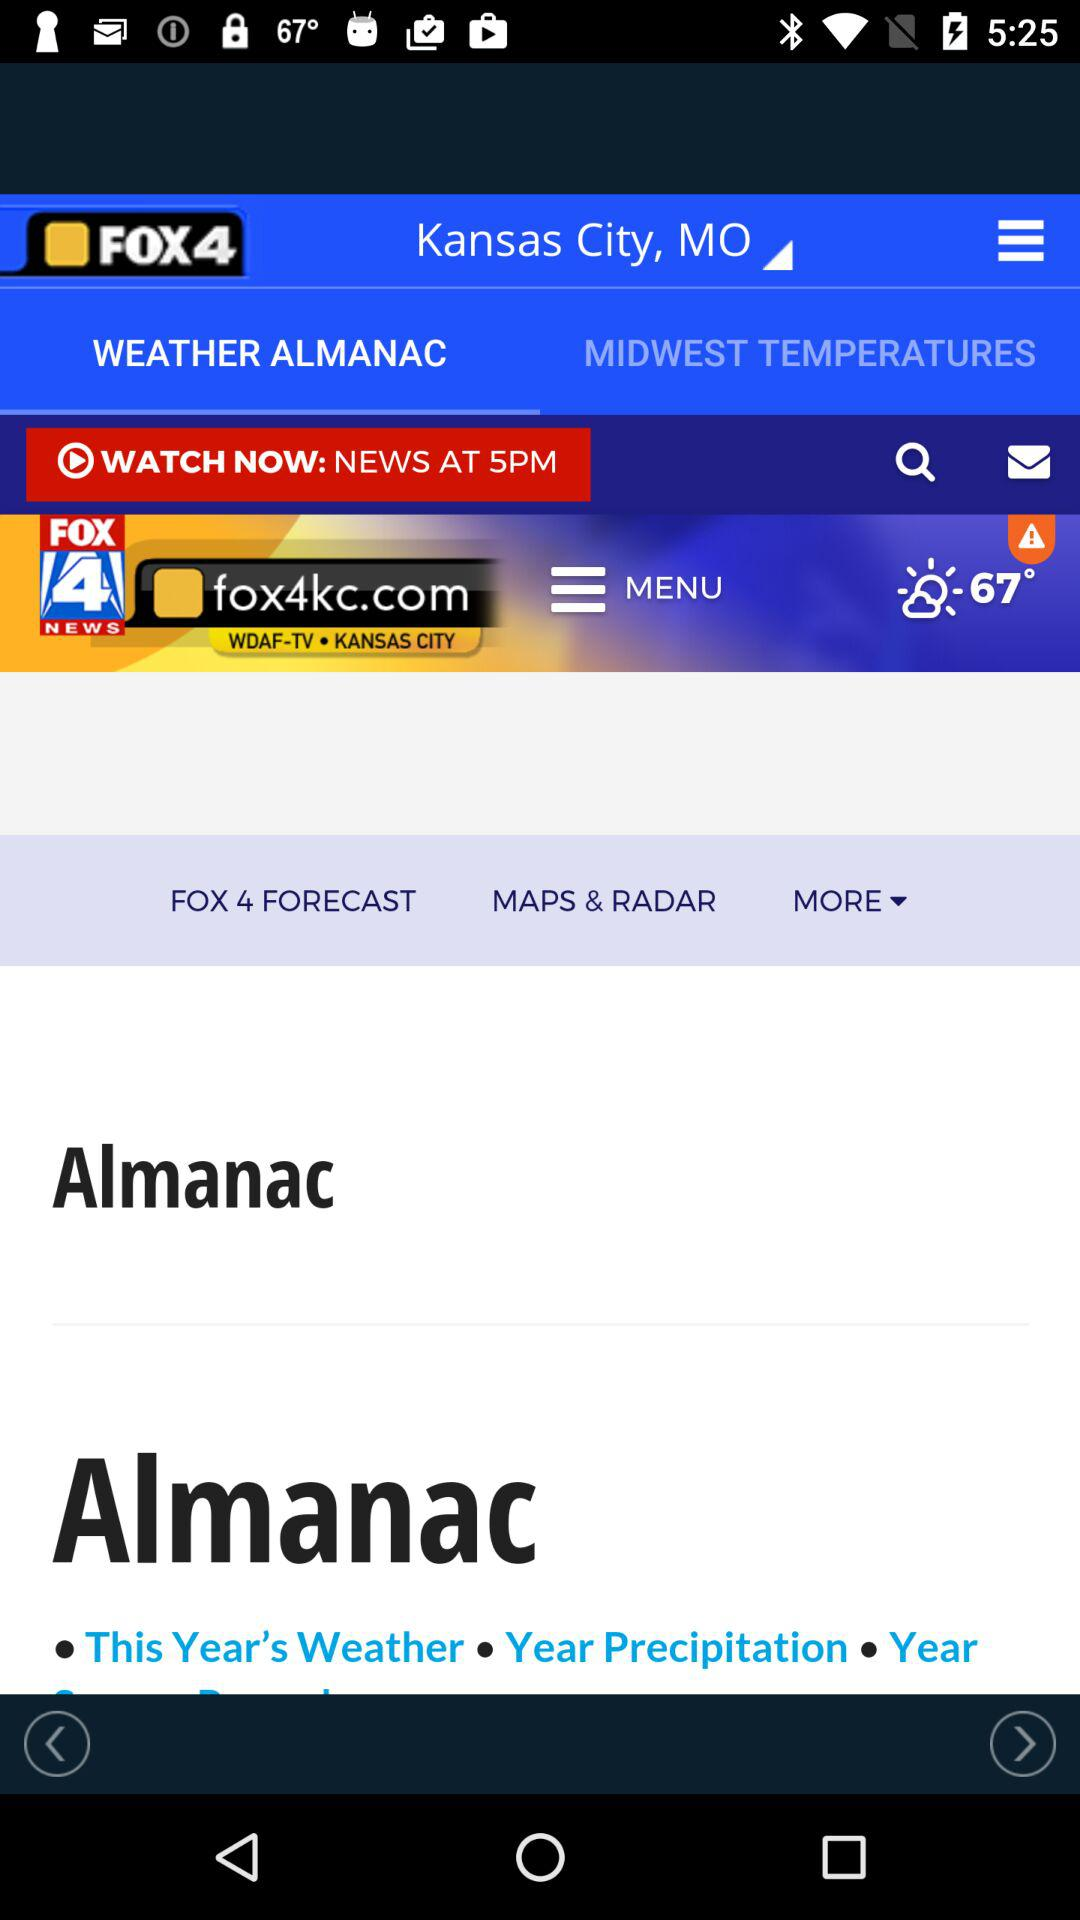What is the temperature in the city? The temperature in the city is 67°. 